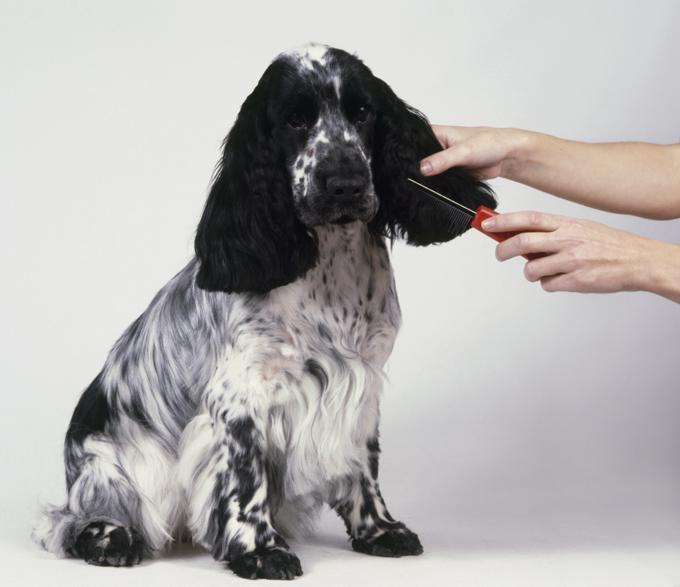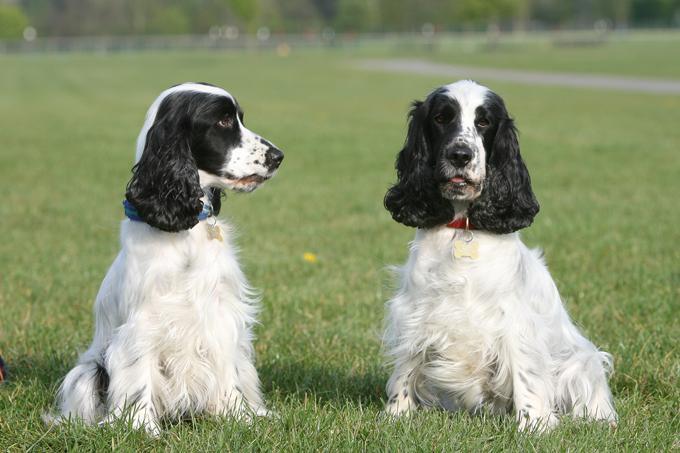The first image is the image on the left, the second image is the image on the right. Given the left and right images, does the statement "There are three dogs in one of the images." hold true? Answer yes or no. No. 